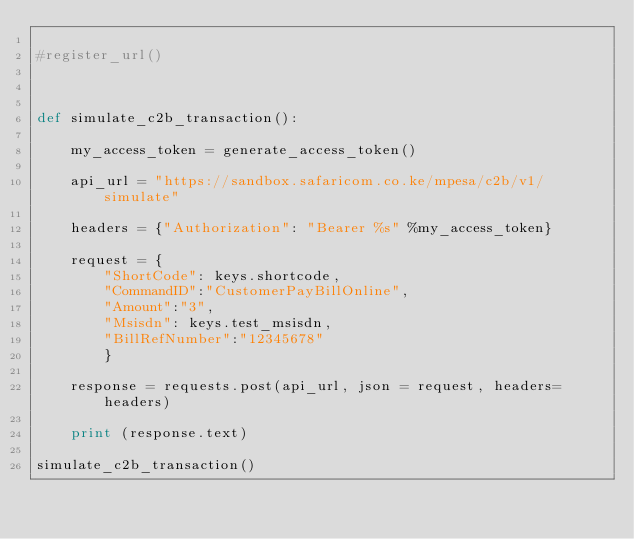Convert code to text. <code><loc_0><loc_0><loc_500><loc_500><_Python_>
#register_url()



def simulate_c2b_transaction():
    
    my_access_token = generate_access_token()
    
    api_url = "https://sandbox.safaricom.co.ke/mpesa/c2b/v1/simulate"
    
    headers = {"Authorization": "Bearer %s" %my_access_token}

    request = { 
        "ShortCode": keys.shortcode,
        "CommandID":"CustomerPayBillOnline",
        "Amount":"3",
        "Msisdn": keys.test_msisdn,
        "BillRefNumber":"12345678" 
        }
    
    response = requests.post(api_url, json = request, headers=headers)
    
    print (response.text)
    
simulate_c2b_transaction()</code> 